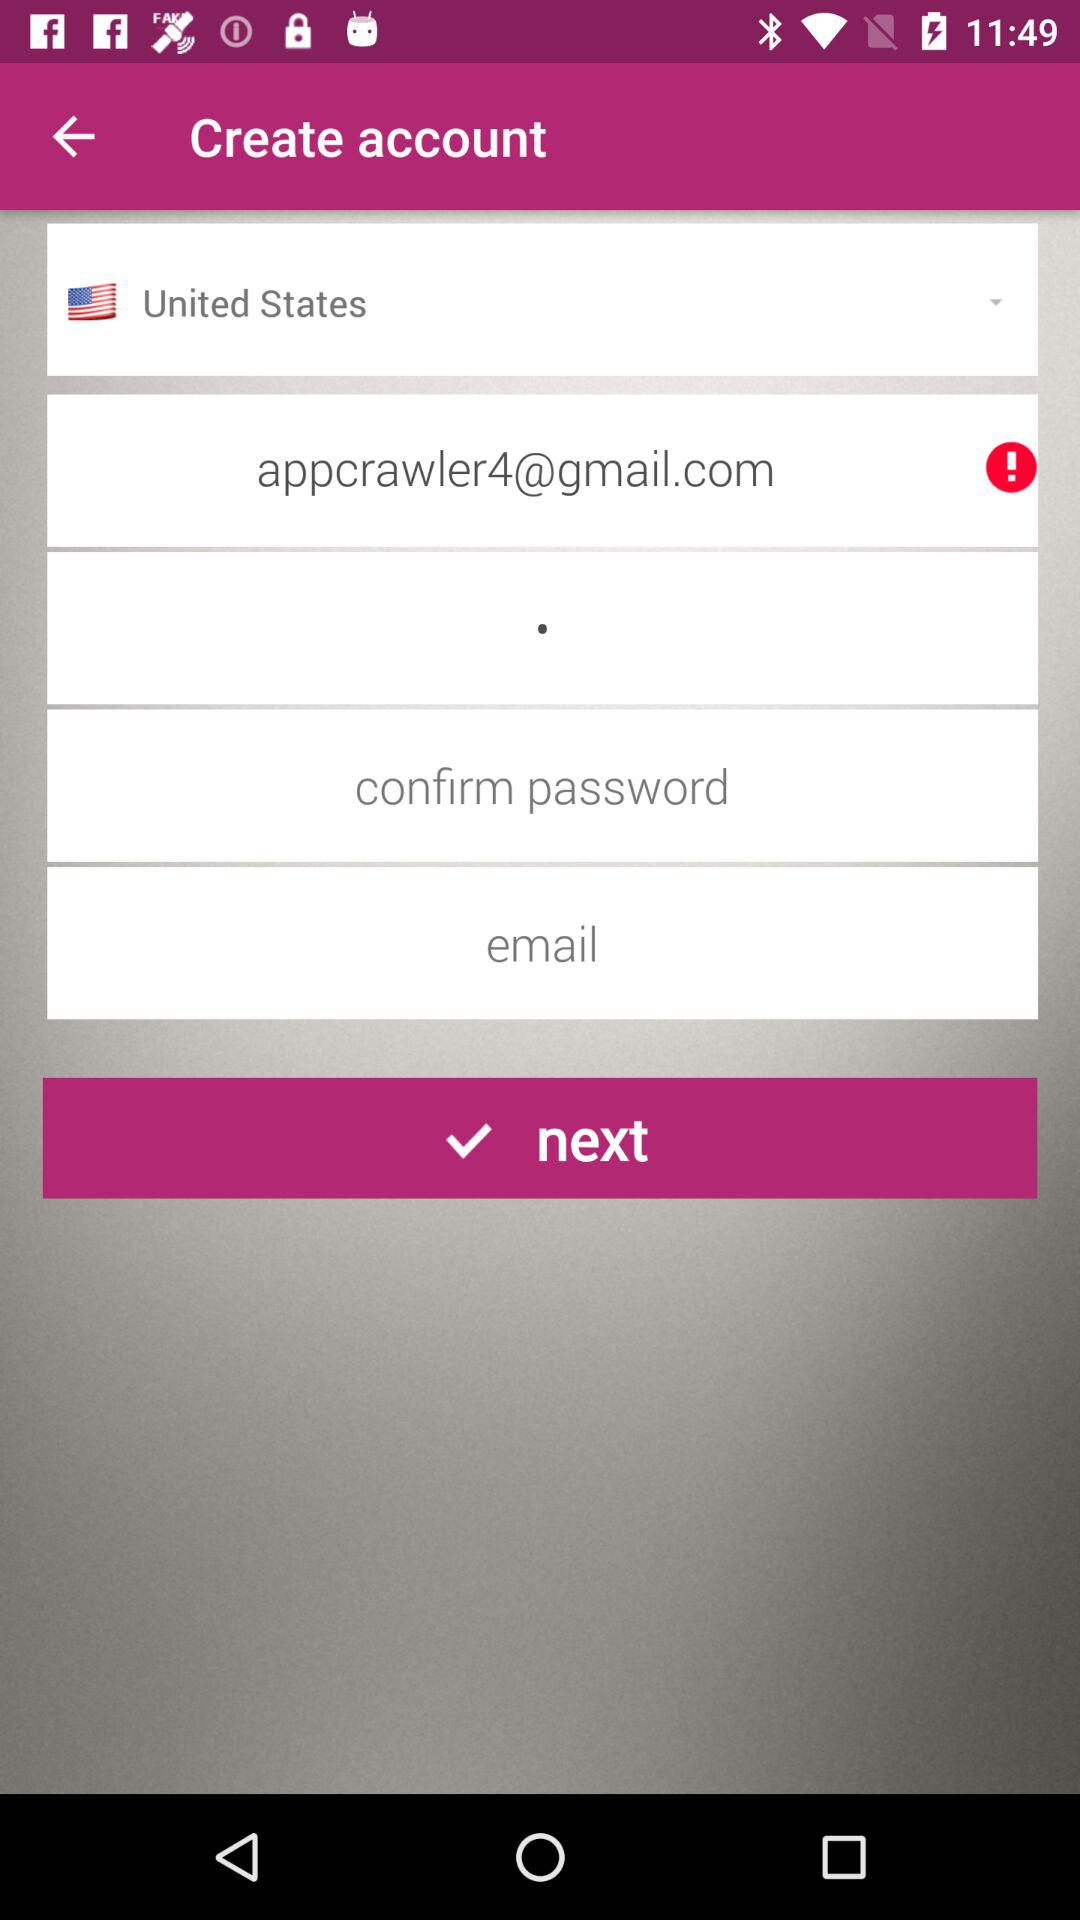Which is the selected country? The selected country is the United States. 